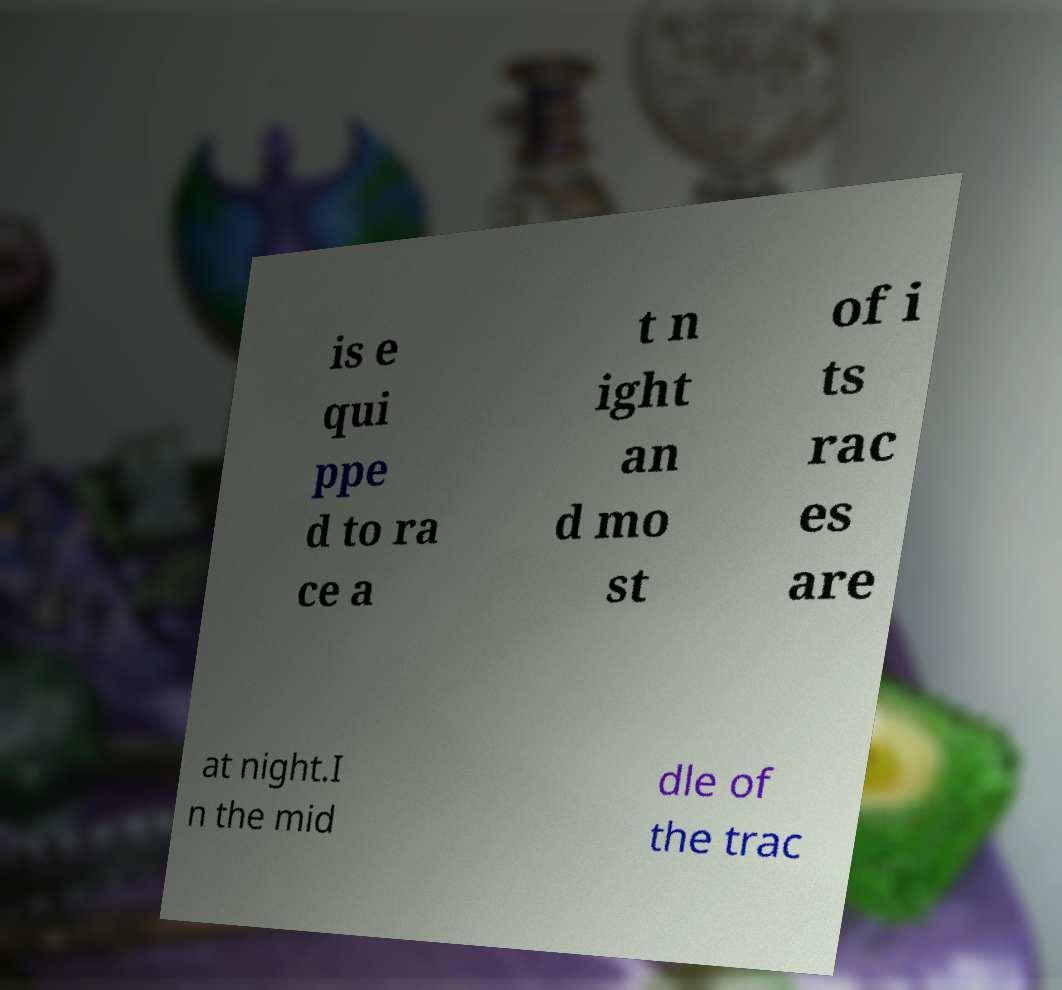What messages or text are displayed in this image? I need them in a readable, typed format. is e qui ppe d to ra ce a t n ight an d mo st of i ts rac es are at night.I n the mid dle of the trac 